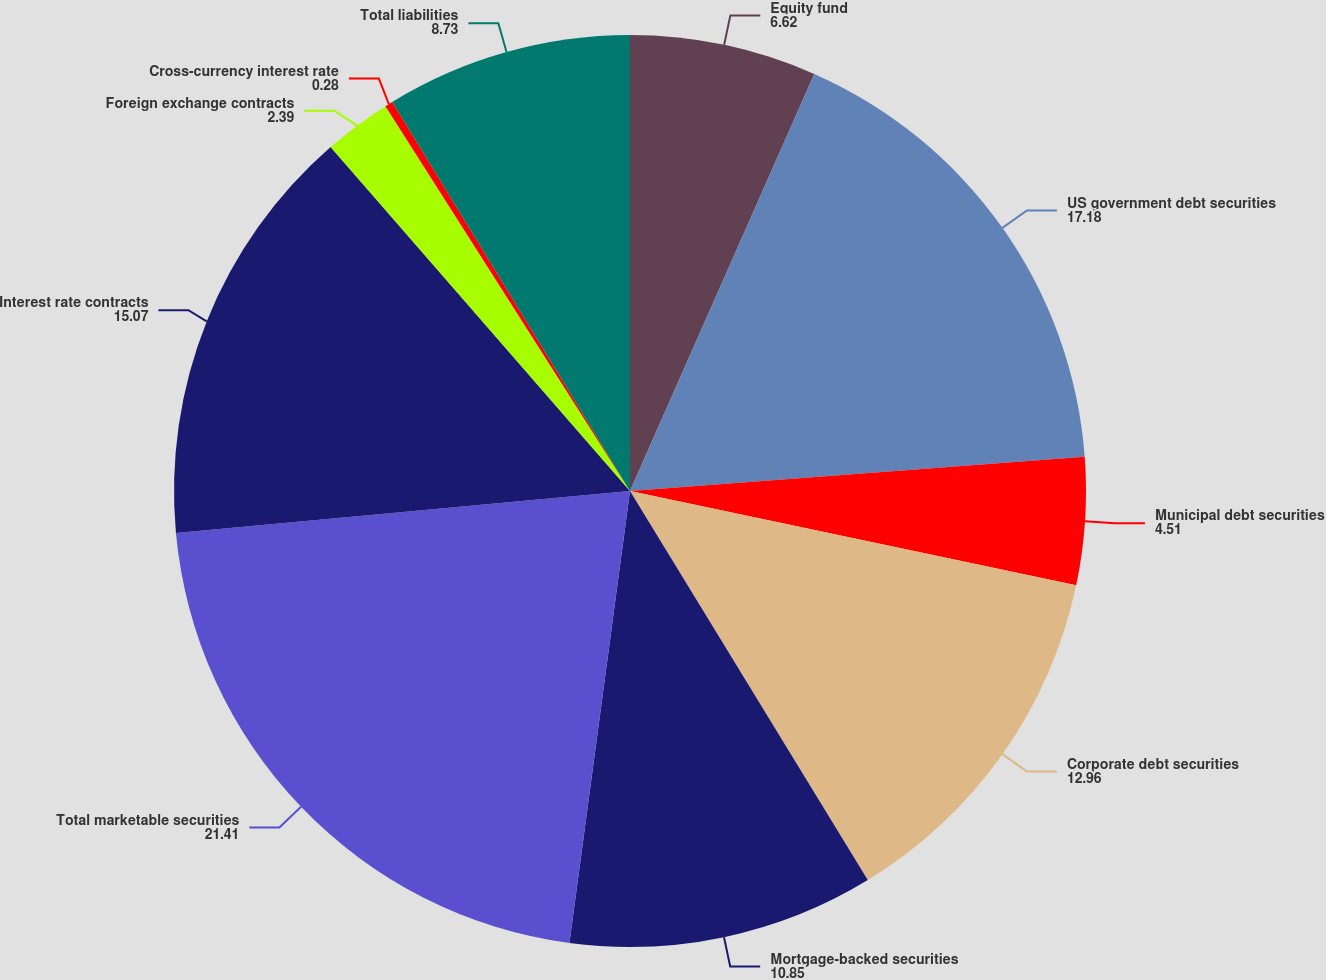Convert chart. <chart><loc_0><loc_0><loc_500><loc_500><pie_chart><fcel>Equity fund<fcel>US government debt securities<fcel>Municipal debt securities<fcel>Corporate debt securities<fcel>Mortgage-backed securities<fcel>Total marketable securities<fcel>Interest rate contracts<fcel>Foreign exchange contracts<fcel>Cross-currency interest rate<fcel>Total liabilities<nl><fcel>6.62%<fcel>17.18%<fcel>4.51%<fcel>12.96%<fcel>10.85%<fcel>21.41%<fcel>15.07%<fcel>2.39%<fcel>0.28%<fcel>8.73%<nl></chart> 